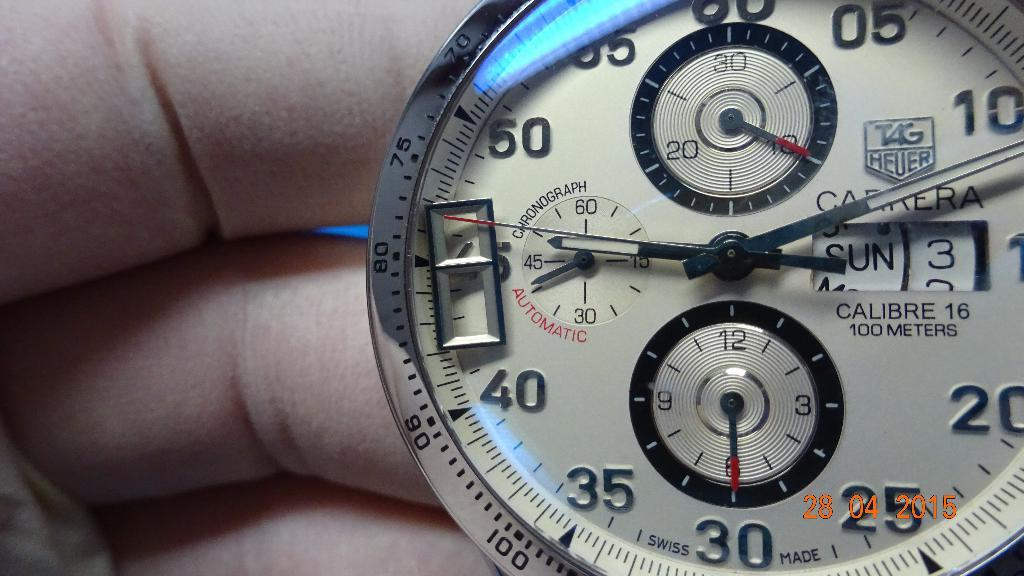<image>
Render a clear and concise summary of the photo. a person is holding a watch that goes 100 meters underwater 